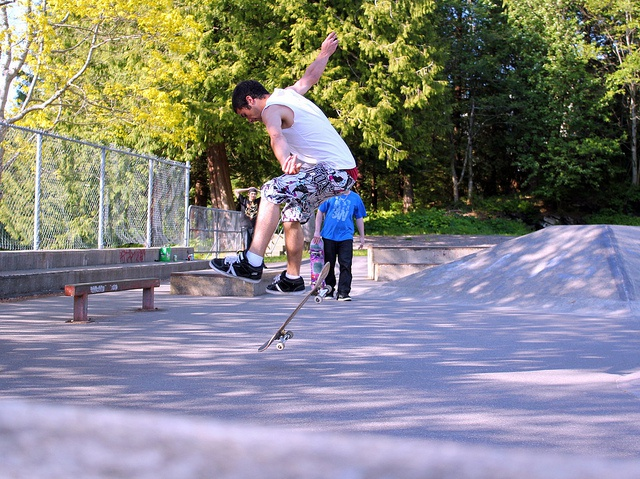Describe the objects in this image and their specific colors. I can see people in lavender, black, and darkgray tones, people in lavender, black, blue, lightblue, and darkgray tones, people in lavender, black, gray, and white tones, skateboard in lavender, darkgray, and gray tones, and skateboard in lavender, gray, and darkgray tones in this image. 